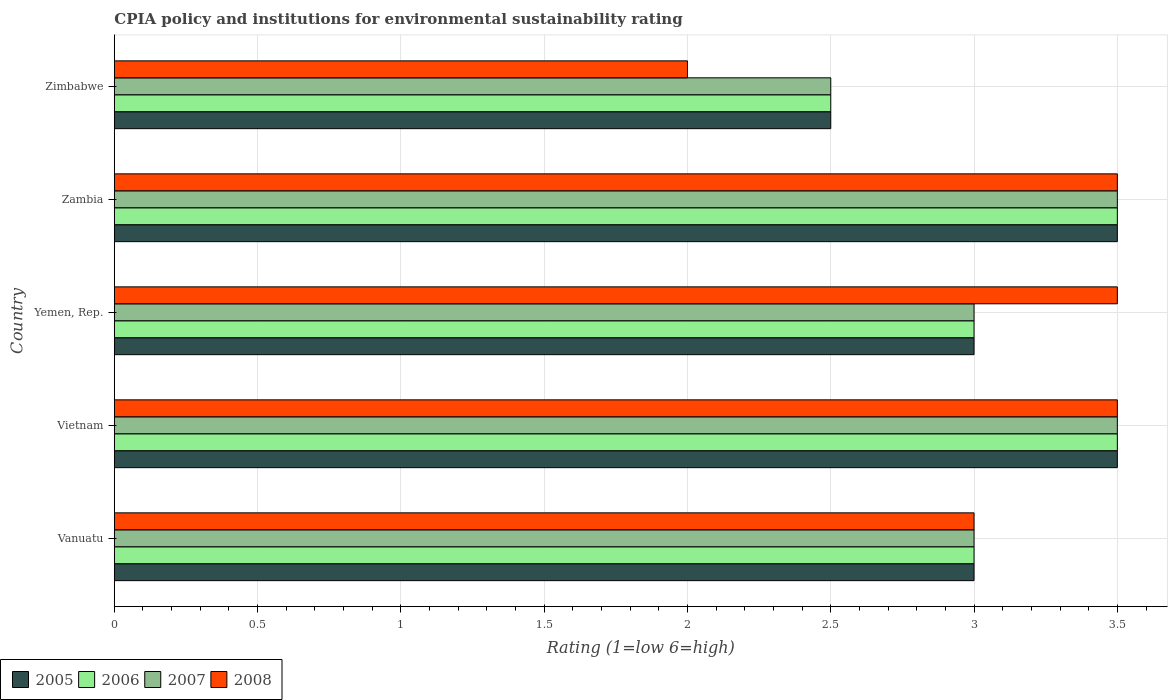How many groups of bars are there?
Your answer should be very brief. 5. Are the number of bars on each tick of the Y-axis equal?
Ensure brevity in your answer.  Yes. How many bars are there on the 1st tick from the top?
Your answer should be very brief. 4. How many bars are there on the 3rd tick from the bottom?
Give a very brief answer. 4. What is the label of the 5th group of bars from the top?
Your answer should be compact. Vanuatu. In how many cases, is the number of bars for a given country not equal to the number of legend labels?
Your answer should be compact. 0. What is the CPIA rating in 2008 in Zambia?
Offer a terse response. 3.5. In which country was the CPIA rating in 2007 maximum?
Keep it short and to the point. Vietnam. In which country was the CPIA rating in 2006 minimum?
Ensure brevity in your answer.  Zimbabwe. What is the difference between the CPIA rating in 2008 and CPIA rating in 2007 in Vanuatu?
Provide a short and direct response. 0. In how many countries, is the CPIA rating in 2007 greater than 0.5 ?
Your response must be concise. 5. Is the CPIA rating in 2008 in Vanuatu less than that in Yemen, Rep.?
Your answer should be compact. Yes. Is the sum of the CPIA rating in 2007 in Vietnam and Yemen, Rep. greater than the maximum CPIA rating in 2005 across all countries?
Offer a very short reply. Yes. How many bars are there?
Your answer should be compact. 20. Are all the bars in the graph horizontal?
Your response must be concise. Yes. How many countries are there in the graph?
Your answer should be very brief. 5. What is the difference between two consecutive major ticks on the X-axis?
Provide a short and direct response. 0.5. Are the values on the major ticks of X-axis written in scientific E-notation?
Offer a very short reply. No. Does the graph contain any zero values?
Provide a short and direct response. No. Does the graph contain grids?
Keep it short and to the point. Yes. How are the legend labels stacked?
Offer a very short reply. Horizontal. What is the title of the graph?
Ensure brevity in your answer.  CPIA policy and institutions for environmental sustainability rating. What is the Rating (1=low 6=high) of 2008 in Vanuatu?
Your response must be concise. 3. What is the Rating (1=low 6=high) of 2005 in Vietnam?
Provide a short and direct response. 3.5. What is the Rating (1=low 6=high) of 2007 in Vietnam?
Keep it short and to the point. 3.5. What is the Rating (1=low 6=high) of 2005 in Yemen, Rep.?
Ensure brevity in your answer.  3. What is the Rating (1=low 6=high) of 2007 in Yemen, Rep.?
Your response must be concise. 3. What is the Rating (1=low 6=high) in 2008 in Yemen, Rep.?
Your response must be concise. 3.5. What is the Rating (1=low 6=high) in 2005 in Zambia?
Provide a succinct answer. 3.5. What is the Rating (1=low 6=high) in 2006 in Zambia?
Ensure brevity in your answer.  3.5. What is the Rating (1=low 6=high) of 2008 in Zambia?
Your response must be concise. 3.5. What is the Rating (1=low 6=high) of 2005 in Zimbabwe?
Ensure brevity in your answer.  2.5. What is the Rating (1=low 6=high) of 2007 in Zimbabwe?
Your answer should be very brief. 2.5. What is the Rating (1=low 6=high) in 2008 in Zimbabwe?
Give a very brief answer. 2. Across all countries, what is the maximum Rating (1=low 6=high) of 2005?
Keep it short and to the point. 3.5. Across all countries, what is the maximum Rating (1=low 6=high) of 2006?
Give a very brief answer. 3.5. Across all countries, what is the maximum Rating (1=low 6=high) in 2007?
Your answer should be very brief. 3.5. Across all countries, what is the maximum Rating (1=low 6=high) in 2008?
Give a very brief answer. 3.5. Across all countries, what is the minimum Rating (1=low 6=high) of 2005?
Your response must be concise. 2.5. Across all countries, what is the minimum Rating (1=low 6=high) in 2006?
Your answer should be compact. 2.5. Across all countries, what is the minimum Rating (1=low 6=high) in 2008?
Keep it short and to the point. 2. What is the difference between the Rating (1=low 6=high) of 2005 in Vanuatu and that in Vietnam?
Provide a succinct answer. -0.5. What is the difference between the Rating (1=low 6=high) in 2006 in Vanuatu and that in Vietnam?
Keep it short and to the point. -0.5. What is the difference between the Rating (1=low 6=high) in 2007 in Vanuatu and that in Vietnam?
Provide a succinct answer. -0.5. What is the difference between the Rating (1=low 6=high) of 2005 in Vanuatu and that in Zambia?
Provide a succinct answer. -0.5. What is the difference between the Rating (1=low 6=high) of 2007 in Vanuatu and that in Zambia?
Your response must be concise. -0.5. What is the difference between the Rating (1=low 6=high) in 2008 in Vanuatu and that in Zambia?
Keep it short and to the point. -0.5. What is the difference between the Rating (1=low 6=high) in 2005 in Vanuatu and that in Zimbabwe?
Give a very brief answer. 0.5. What is the difference between the Rating (1=low 6=high) in 2006 in Vanuatu and that in Zimbabwe?
Your answer should be very brief. 0.5. What is the difference between the Rating (1=low 6=high) in 2008 in Vanuatu and that in Zimbabwe?
Your response must be concise. 1. What is the difference between the Rating (1=low 6=high) in 2005 in Vietnam and that in Yemen, Rep.?
Your answer should be compact. 0.5. What is the difference between the Rating (1=low 6=high) of 2008 in Vietnam and that in Yemen, Rep.?
Your answer should be very brief. 0. What is the difference between the Rating (1=low 6=high) in 2005 in Vietnam and that in Zambia?
Make the answer very short. 0. What is the difference between the Rating (1=low 6=high) in 2006 in Vietnam and that in Zambia?
Ensure brevity in your answer.  0. What is the difference between the Rating (1=low 6=high) of 2007 in Vietnam and that in Zambia?
Offer a very short reply. 0. What is the difference between the Rating (1=low 6=high) in 2005 in Vietnam and that in Zimbabwe?
Your answer should be compact. 1. What is the difference between the Rating (1=low 6=high) in 2008 in Vietnam and that in Zimbabwe?
Your answer should be compact. 1.5. What is the difference between the Rating (1=low 6=high) in 2006 in Yemen, Rep. and that in Zambia?
Provide a short and direct response. -0.5. What is the difference between the Rating (1=low 6=high) of 2007 in Yemen, Rep. and that in Zambia?
Make the answer very short. -0.5. What is the difference between the Rating (1=low 6=high) in 2005 in Yemen, Rep. and that in Zimbabwe?
Provide a short and direct response. 0.5. What is the difference between the Rating (1=low 6=high) of 2007 in Yemen, Rep. and that in Zimbabwe?
Keep it short and to the point. 0.5. What is the difference between the Rating (1=low 6=high) in 2008 in Zambia and that in Zimbabwe?
Give a very brief answer. 1.5. What is the difference between the Rating (1=low 6=high) of 2005 in Vanuatu and the Rating (1=low 6=high) of 2007 in Vietnam?
Offer a very short reply. -0.5. What is the difference between the Rating (1=low 6=high) of 2007 in Vanuatu and the Rating (1=low 6=high) of 2008 in Vietnam?
Ensure brevity in your answer.  -0.5. What is the difference between the Rating (1=low 6=high) of 2005 in Vanuatu and the Rating (1=low 6=high) of 2006 in Yemen, Rep.?
Your response must be concise. 0. What is the difference between the Rating (1=low 6=high) of 2005 in Vanuatu and the Rating (1=low 6=high) of 2007 in Yemen, Rep.?
Provide a short and direct response. 0. What is the difference between the Rating (1=low 6=high) of 2006 in Vanuatu and the Rating (1=low 6=high) of 2007 in Yemen, Rep.?
Provide a short and direct response. 0. What is the difference between the Rating (1=low 6=high) of 2007 in Vanuatu and the Rating (1=low 6=high) of 2008 in Yemen, Rep.?
Your response must be concise. -0.5. What is the difference between the Rating (1=low 6=high) in 2005 in Vanuatu and the Rating (1=low 6=high) in 2007 in Zambia?
Your answer should be compact. -0.5. What is the difference between the Rating (1=low 6=high) in 2006 in Vanuatu and the Rating (1=low 6=high) in 2007 in Zambia?
Offer a very short reply. -0.5. What is the difference between the Rating (1=low 6=high) in 2006 in Vanuatu and the Rating (1=low 6=high) in 2008 in Zambia?
Make the answer very short. -0.5. What is the difference between the Rating (1=low 6=high) in 2007 in Vanuatu and the Rating (1=low 6=high) in 2008 in Zambia?
Offer a very short reply. -0.5. What is the difference between the Rating (1=low 6=high) in 2005 in Vanuatu and the Rating (1=low 6=high) in 2008 in Zimbabwe?
Make the answer very short. 1. What is the difference between the Rating (1=low 6=high) of 2007 in Vanuatu and the Rating (1=low 6=high) of 2008 in Zimbabwe?
Provide a succinct answer. 1. What is the difference between the Rating (1=low 6=high) in 2006 in Vietnam and the Rating (1=low 6=high) in 2008 in Yemen, Rep.?
Provide a succinct answer. 0. What is the difference between the Rating (1=low 6=high) in 2005 in Vietnam and the Rating (1=low 6=high) in 2008 in Zambia?
Ensure brevity in your answer.  0. What is the difference between the Rating (1=low 6=high) of 2006 in Vietnam and the Rating (1=low 6=high) of 2007 in Zambia?
Offer a very short reply. 0. What is the difference between the Rating (1=low 6=high) of 2006 in Vietnam and the Rating (1=low 6=high) of 2008 in Zambia?
Your answer should be very brief. 0. What is the difference between the Rating (1=low 6=high) of 2007 in Vietnam and the Rating (1=low 6=high) of 2008 in Zambia?
Ensure brevity in your answer.  0. What is the difference between the Rating (1=low 6=high) in 2005 in Vietnam and the Rating (1=low 6=high) in 2008 in Zimbabwe?
Ensure brevity in your answer.  1.5. What is the difference between the Rating (1=low 6=high) in 2006 in Vietnam and the Rating (1=low 6=high) in 2008 in Zimbabwe?
Offer a terse response. 1.5. What is the difference between the Rating (1=low 6=high) of 2005 in Yemen, Rep. and the Rating (1=low 6=high) of 2006 in Zambia?
Make the answer very short. -0.5. What is the difference between the Rating (1=low 6=high) of 2005 in Yemen, Rep. and the Rating (1=low 6=high) of 2007 in Zambia?
Provide a succinct answer. -0.5. What is the difference between the Rating (1=low 6=high) in 2005 in Yemen, Rep. and the Rating (1=low 6=high) in 2008 in Zambia?
Keep it short and to the point. -0.5. What is the difference between the Rating (1=low 6=high) of 2006 in Yemen, Rep. and the Rating (1=low 6=high) of 2008 in Zambia?
Offer a terse response. -0.5. What is the difference between the Rating (1=low 6=high) in 2005 in Yemen, Rep. and the Rating (1=low 6=high) in 2008 in Zimbabwe?
Offer a terse response. 1. What is the difference between the Rating (1=low 6=high) in 2006 in Yemen, Rep. and the Rating (1=low 6=high) in 2008 in Zimbabwe?
Offer a very short reply. 1. What is the difference between the Rating (1=low 6=high) in 2005 in Zambia and the Rating (1=low 6=high) in 2007 in Zimbabwe?
Provide a succinct answer. 1. What is the difference between the Rating (1=low 6=high) in 2006 in Zambia and the Rating (1=low 6=high) in 2008 in Zimbabwe?
Your response must be concise. 1.5. What is the difference between the Rating (1=low 6=high) of 2007 in Zambia and the Rating (1=low 6=high) of 2008 in Zimbabwe?
Make the answer very short. 1.5. What is the average Rating (1=low 6=high) of 2005 per country?
Make the answer very short. 3.1. What is the average Rating (1=low 6=high) of 2006 per country?
Your answer should be compact. 3.1. What is the average Rating (1=low 6=high) in 2007 per country?
Your answer should be very brief. 3.1. What is the difference between the Rating (1=low 6=high) of 2005 and Rating (1=low 6=high) of 2006 in Vanuatu?
Ensure brevity in your answer.  0. What is the difference between the Rating (1=low 6=high) of 2005 and Rating (1=low 6=high) of 2008 in Vanuatu?
Ensure brevity in your answer.  0. What is the difference between the Rating (1=low 6=high) of 2006 and Rating (1=low 6=high) of 2008 in Vanuatu?
Your answer should be very brief. 0. What is the difference between the Rating (1=low 6=high) of 2005 and Rating (1=low 6=high) of 2006 in Vietnam?
Give a very brief answer. 0. What is the difference between the Rating (1=low 6=high) in 2006 and Rating (1=low 6=high) in 2007 in Vietnam?
Offer a terse response. 0. What is the difference between the Rating (1=low 6=high) in 2007 and Rating (1=low 6=high) in 2008 in Vietnam?
Keep it short and to the point. 0. What is the difference between the Rating (1=low 6=high) in 2005 and Rating (1=low 6=high) in 2007 in Yemen, Rep.?
Your answer should be compact. 0. What is the difference between the Rating (1=low 6=high) in 2007 and Rating (1=low 6=high) in 2008 in Yemen, Rep.?
Make the answer very short. -0.5. What is the difference between the Rating (1=low 6=high) of 2005 and Rating (1=low 6=high) of 2006 in Zambia?
Your answer should be very brief. 0. What is the difference between the Rating (1=low 6=high) of 2005 and Rating (1=low 6=high) of 2007 in Zambia?
Give a very brief answer. 0. What is the difference between the Rating (1=low 6=high) of 2005 and Rating (1=low 6=high) of 2008 in Zambia?
Provide a short and direct response. 0. What is the difference between the Rating (1=low 6=high) of 2005 and Rating (1=low 6=high) of 2006 in Zimbabwe?
Provide a succinct answer. 0. What is the difference between the Rating (1=low 6=high) in 2005 and Rating (1=low 6=high) in 2008 in Zimbabwe?
Ensure brevity in your answer.  0.5. What is the difference between the Rating (1=low 6=high) of 2006 and Rating (1=low 6=high) of 2007 in Zimbabwe?
Give a very brief answer. 0. What is the difference between the Rating (1=low 6=high) in 2006 and Rating (1=low 6=high) in 2008 in Zimbabwe?
Keep it short and to the point. 0.5. What is the difference between the Rating (1=low 6=high) in 2007 and Rating (1=low 6=high) in 2008 in Zimbabwe?
Make the answer very short. 0.5. What is the ratio of the Rating (1=low 6=high) in 2005 in Vanuatu to that in Vietnam?
Give a very brief answer. 0.86. What is the ratio of the Rating (1=low 6=high) of 2008 in Vanuatu to that in Vietnam?
Offer a terse response. 0.86. What is the ratio of the Rating (1=low 6=high) in 2006 in Vanuatu to that in Yemen, Rep.?
Offer a very short reply. 1. What is the ratio of the Rating (1=low 6=high) of 2007 in Vanuatu to that in Yemen, Rep.?
Offer a terse response. 1. What is the ratio of the Rating (1=low 6=high) in 2008 in Vanuatu to that in Yemen, Rep.?
Your answer should be very brief. 0.86. What is the ratio of the Rating (1=low 6=high) of 2005 in Vanuatu to that in Zambia?
Keep it short and to the point. 0.86. What is the ratio of the Rating (1=low 6=high) of 2007 in Vanuatu to that in Zambia?
Provide a succinct answer. 0.86. What is the ratio of the Rating (1=low 6=high) of 2006 in Vanuatu to that in Zimbabwe?
Your answer should be very brief. 1.2. What is the ratio of the Rating (1=low 6=high) of 2005 in Vietnam to that in Yemen, Rep.?
Provide a short and direct response. 1.17. What is the ratio of the Rating (1=low 6=high) of 2006 in Vietnam to that in Yemen, Rep.?
Your answer should be compact. 1.17. What is the ratio of the Rating (1=low 6=high) in 2008 in Vietnam to that in Yemen, Rep.?
Offer a terse response. 1. What is the ratio of the Rating (1=low 6=high) in 2008 in Vietnam to that in Zambia?
Provide a succinct answer. 1. What is the ratio of the Rating (1=low 6=high) of 2005 in Vietnam to that in Zimbabwe?
Your answer should be very brief. 1.4. What is the ratio of the Rating (1=low 6=high) of 2006 in Vietnam to that in Zimbabwe?
Your answer should be very brief. 1.4. What is the ratio of the Rating (1=low 6=high) in 2008 in Vietnam to that in Zimbabwe?
Your answer should be compact. 1.75. What is the ratio of the Rating (1=low 6=high) of 2007 in Yemen, Rep. to that in Zambia?
Your response must be concise. 0.86. What is the ratio of the Rating (1=low 6=high) of 2005 in Yemen, Rep. to that in Zimbabwe?
Your response must be concise. 1.2. What is the ratio of the Rating (1=low 6=high) of 2006 in Yemen, Rep. to that in Zimbabwe?
Offer a terse response. 1.2. What is the ratio of the Rating (1=low 6=high) of 2007 in Yemen, Rep. to that in Zimbabwe?
Offer a very short reply. 1.2. What is the ratio of the Rating (1=low 6=high) of 2008 in Yemen, Rep. to that in Zimbabwe?
Provide a succinct answer. 1.75. What is the difference between the highest and the second highest Rating (1=low 6=high) in 2005?
Your answer should be very brief. 0. What is the difference between the highest and the second highest Rating (1=low 6=high) of 2008?
Offer a very short reply. 0. What is the difference between the highest and the lowest Rating (1=low 6=high) of 2005?
Make the answer very short. 1. What is the difference between the highest and the lowest Rating (1=low 6=high) of 2007?
Your answer should be very brief. 1. 